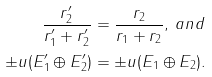Convert formula to latex. <formula><loc_0><loc_0><loc_500><loc_500>\frac { r ^ { \prime } _ { 2 } } { r _ { 1 } ^ { \prime } + r _ { 2 } ^ { \prime } } & = \frac { r _ { 2 } } { r _ { 1 } + r _ { 2 } } , \, a n d \\ \pm u ( E ^ { \prime } _ { 1 } \oplus E ^ { \prime } _ { 2 } ) & = \pm u ( E _ { 1 } \oplus E _ { 2 } ) .</formula> 